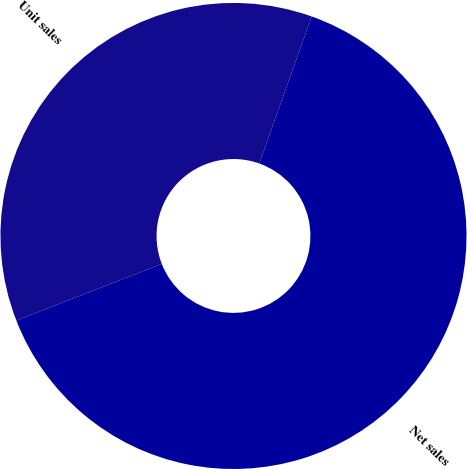Convert chart. <chart><loc_0><loc_0><loc_500><loc_500><pie_chart><fcel>Net sales<fcel>Unit sales<nl><fcel>63.64%<fcel>36.36%<nl></chart> 